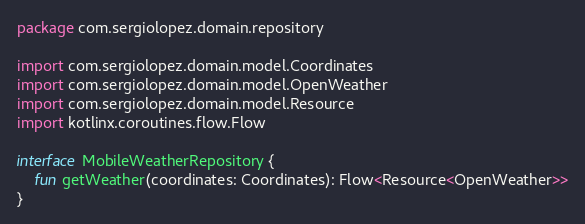Convert code to text. <code><loc_0><loc_0><loc_500><loc_500><_Kotlin_>package com.sergiolopez.domain.repository

import com.sergiolopez.domain.model.Coordinates
import com.sergiolopez.domain.model.OpenWeather
import com.sergiolopez.domain.model.Resource
import kotlinx.coroutines.flow.Flow

interface MobileWeatherRepository {
    fun getWeather(coordinates: Coordinates): Flow<Resource<OpenWeather>>
}
</code> 